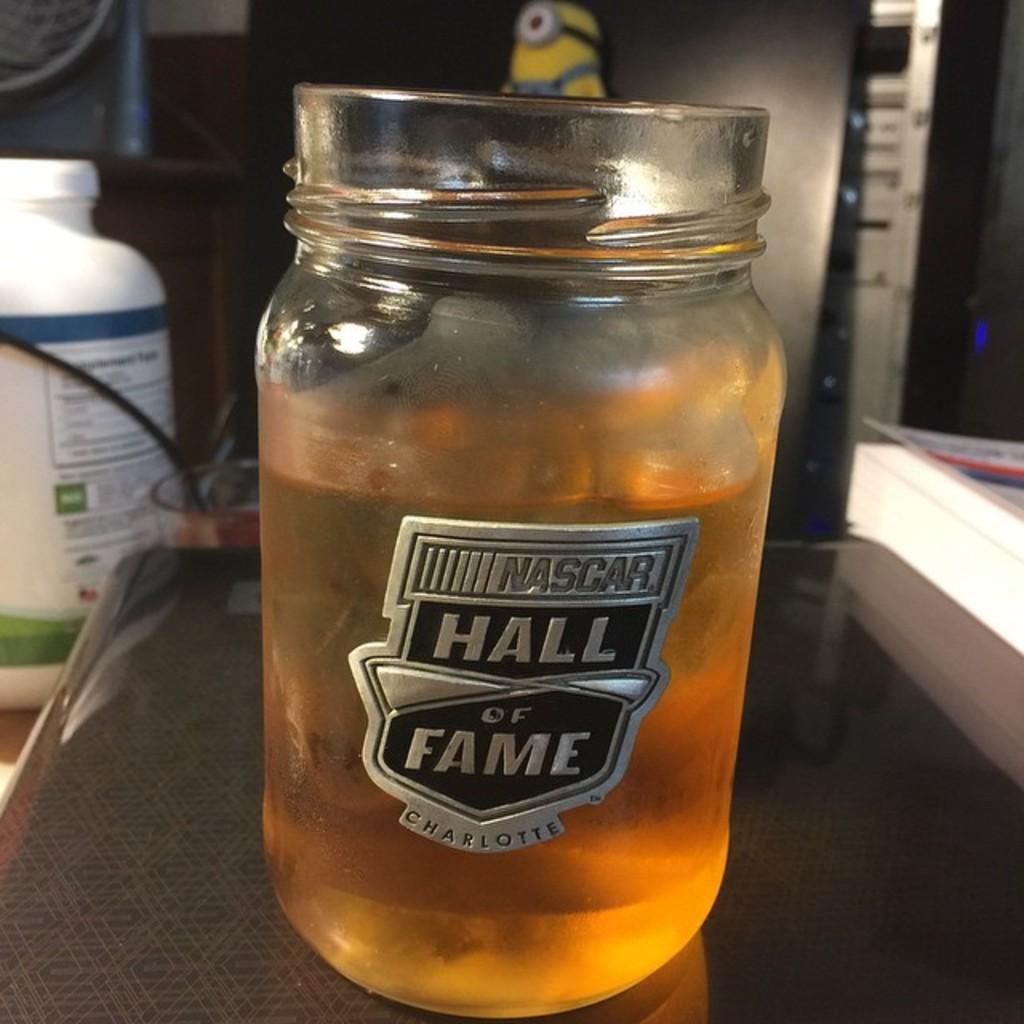Could you give a brief overview of what you see in this image? In the middle of the image, there is a jar filled with a drink placed on a table. In the background, there is a white color bottle, there is a wire and there are other objects. 